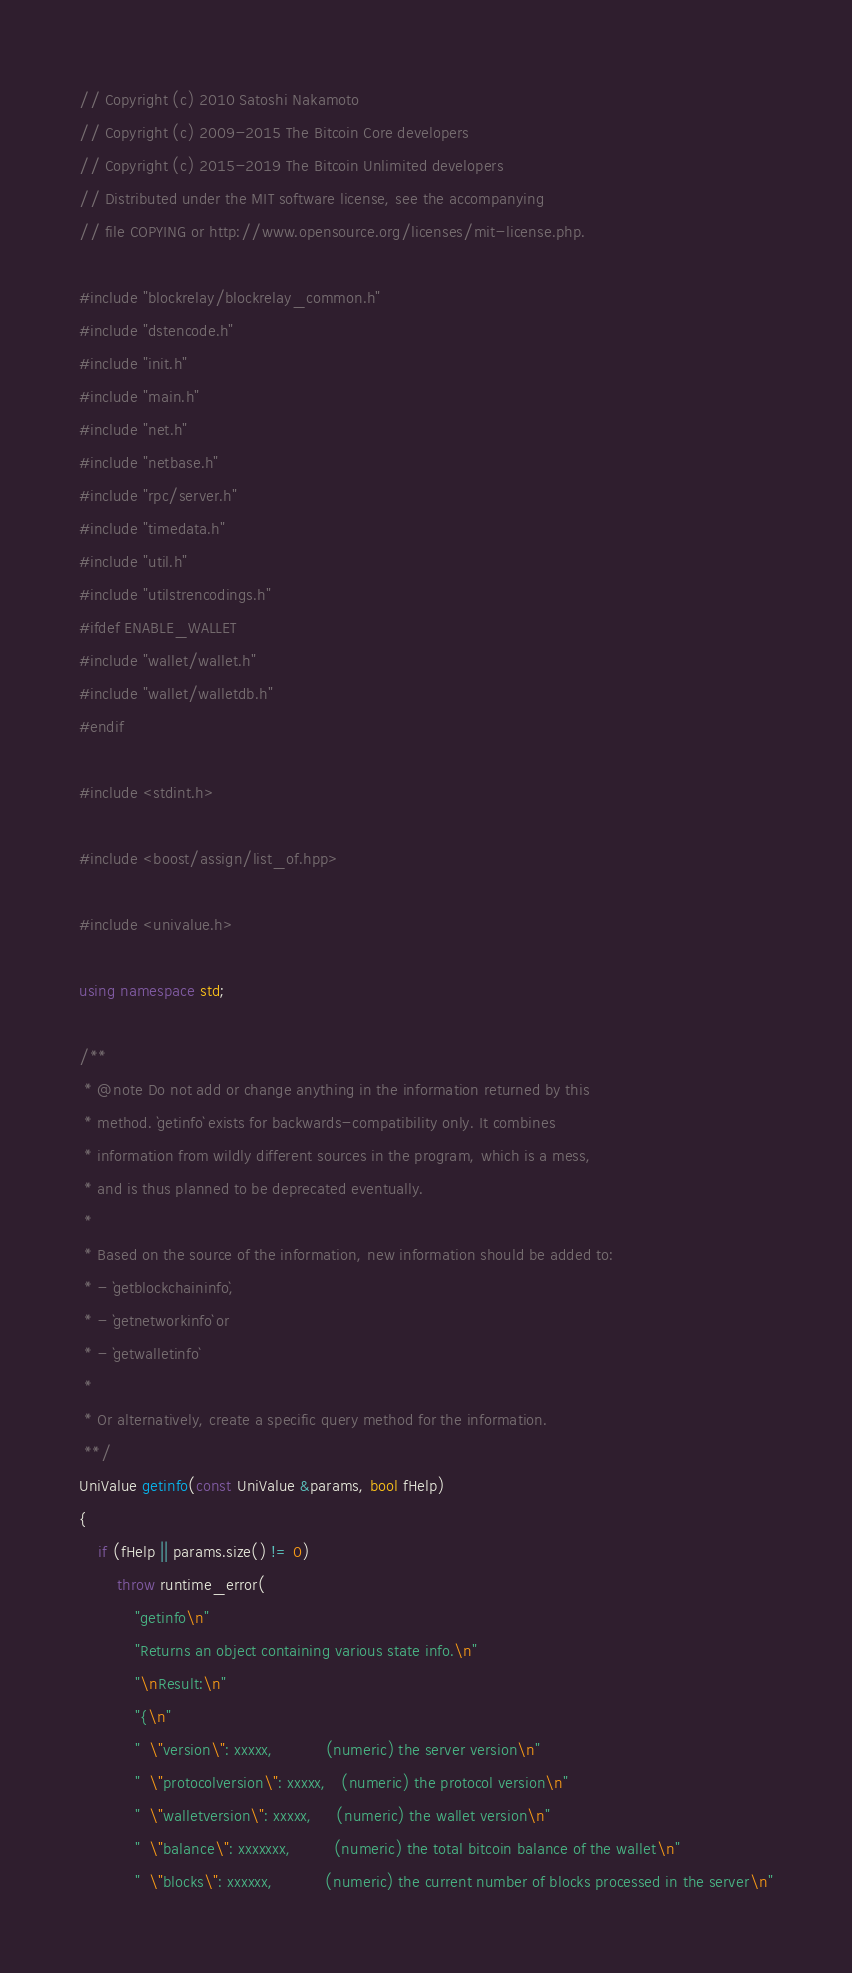<code> <loc_0><loc_0><loc_500><loc_500><_C++_>// Copyright (c) 2010 Satoshi Nakamoto
// Copyright (c) 2009-2015 The Bitcoin Core developers
// Copyright (c) 2015-2019 The Bitcoin Unlimited developers
// Distributed under the MIT software license, see the accompanying
// file COPYING or http://www.opensource.org/licenses/mit-license.php.

#include "blockrelay/blockrelay_common.h"
#include "dstencode.h"
#include "init.h"
#include "main.h"
#include "net.h"
#include "netbase.h"
#include "rpc/server.h"
#include "timedata.h"
#include "util.h"
#include "utilstrencodings.h"
#ifdef ENABLE_WALLET
#include "wallet/wallet.h"
#include "wallet/walletdb.h"
#endif

#include <stdint.h>

#include <boost/assign/list_of.hpp>

#include <univalue.h>

using namespace std;

/**
 * @note Do not add or change anything in the information returned by this
 * method. `getinfo` exists for backwards-compatibility only. It combines
 * information from wildly different sources in the program, which is a mess,
 * and is thus planned to be deprecated eventually.
 *
 * Based on the source of the information, new information should be added to:
 * - `getblockchaininfo`,
 * - `getnetworkinfo` or
 * - `getwalletinfo`
 *
 * Or alternatively, create a specific query method for the information.
 **/
UniValue getinfo(const UniValue &params, bool fHelp)
{
    if (fHelp || params.size() != 0)
        throw runtime_error(
            "getinfo\n"
            "Returns an object containing various state info.\n"
            "\nResult:\n"
            "{\n"
            "  \"version\": xxxxx,           (numeric) the server version\n"
            "  \"protocolversion\": xxxxx,   (numeric) the protocol version\n"
            "  \"walletversion\": xxxxx,     (numeric) the wallet version\n"
            "  \"balance\": xxxxxxx,         (numeric) the total bitcoin balance of the wallet\n"
            "  \"blocks\": xxxxxx,           (numeric) the current number of blocks processed in the server\n"</code> 